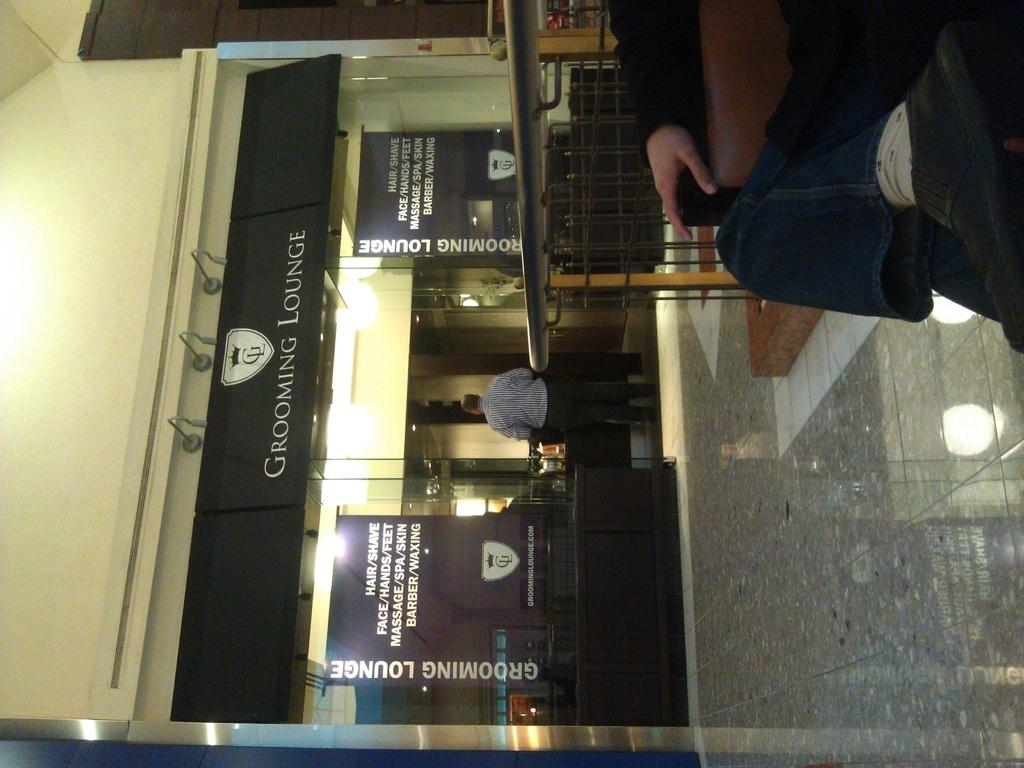What is the main subject in the image? There is a man standing in the image. Where is the man standing? The man is standing on the floor. What else can be seen in the image besides the man? There is a board, banners with text, lights, poles, a metal grill, and a wall visible in the image. What type of skin can be seen on the donkey in the image? There is no donkey present in the image, so there is no skin to observe. What is the man eating from in the image? The provided facts do not mention any food or plate in the image, so it cannot be determined what the man might be eating from. 